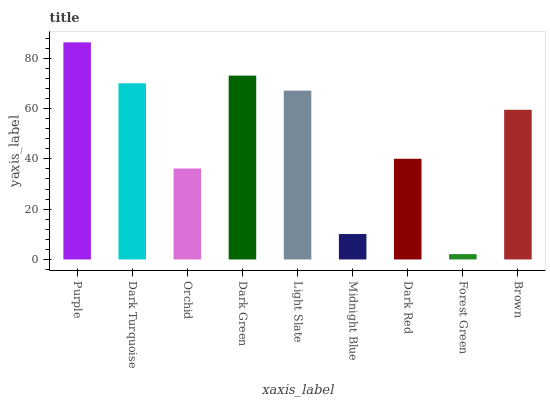Is Forest Green the minimum?
Answer yes or no. Yes. Is Purple the maximum?
Answer yes or no. Yes. Is Dark Turquoise the minimum?
Answer yes or no. No. Is Dark Turquoise the maximum?
Answer yes or no. No. Is Purple greater than Dark Turquoise?
Answer yes or no. Yes. Is Dark Turquoise less than Purple?
Answer yes or no. Yes. Is Dark Turquoise greater than Purple?
Answer yes or no. No. Is Purple less than Dark Turquoise?
Answer yes or no. No. Is Brown the high median?
Answer yes or no. Yes. Is Brown the low median?
Answer yes or no. Yes. Is Midnight Blue the high median?
Answer yes or no. No. Is Orchid the low median?
Answer yes or no. No. 